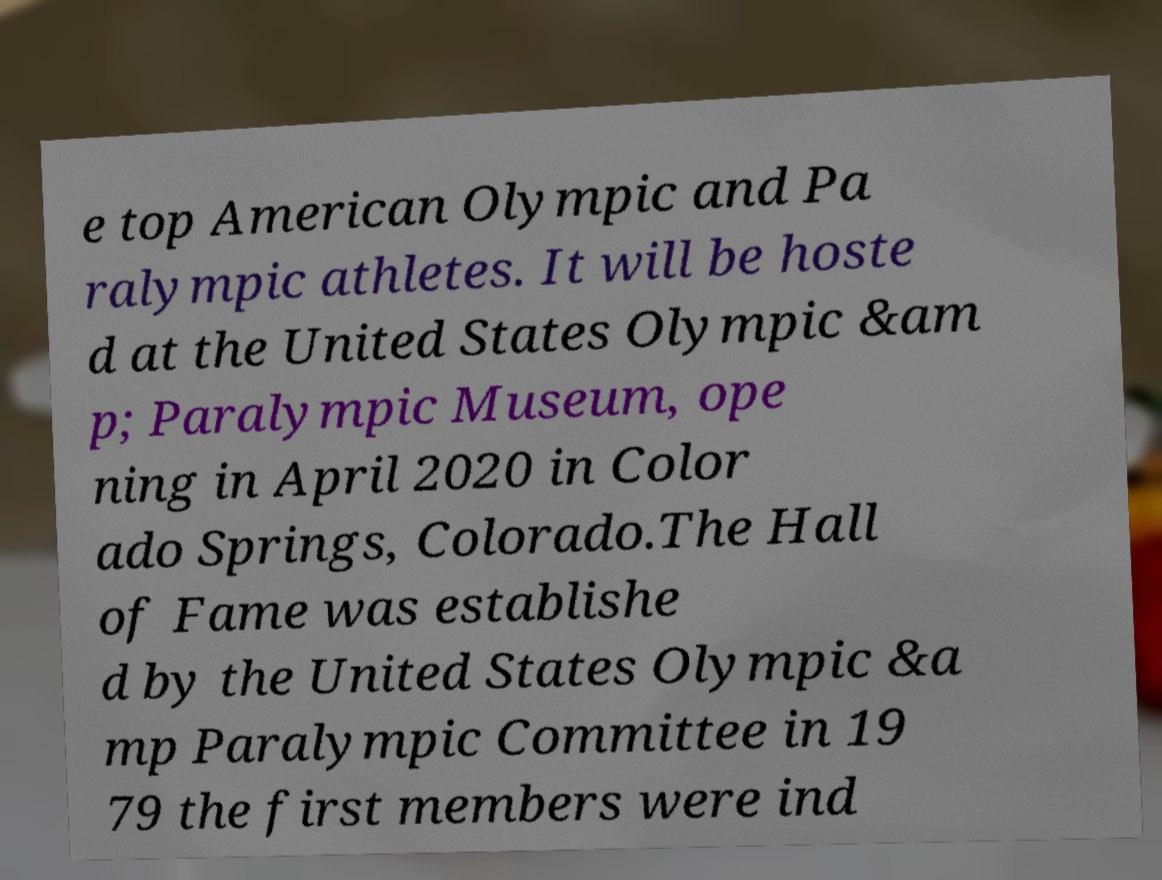Could you assist in decoding the text presented in this image and type it out clearly? e top American Olympic and Pa ralympic athletes. It will be hoste d at the United States Olympic &am p; Paralympic Museum, ope ning in April 2020 in Color ado Springs, Colorado.The Hall of Fame was establishe d by the United States Olympic &a mp Paralympic Committee in 19 79 the first members were ind 